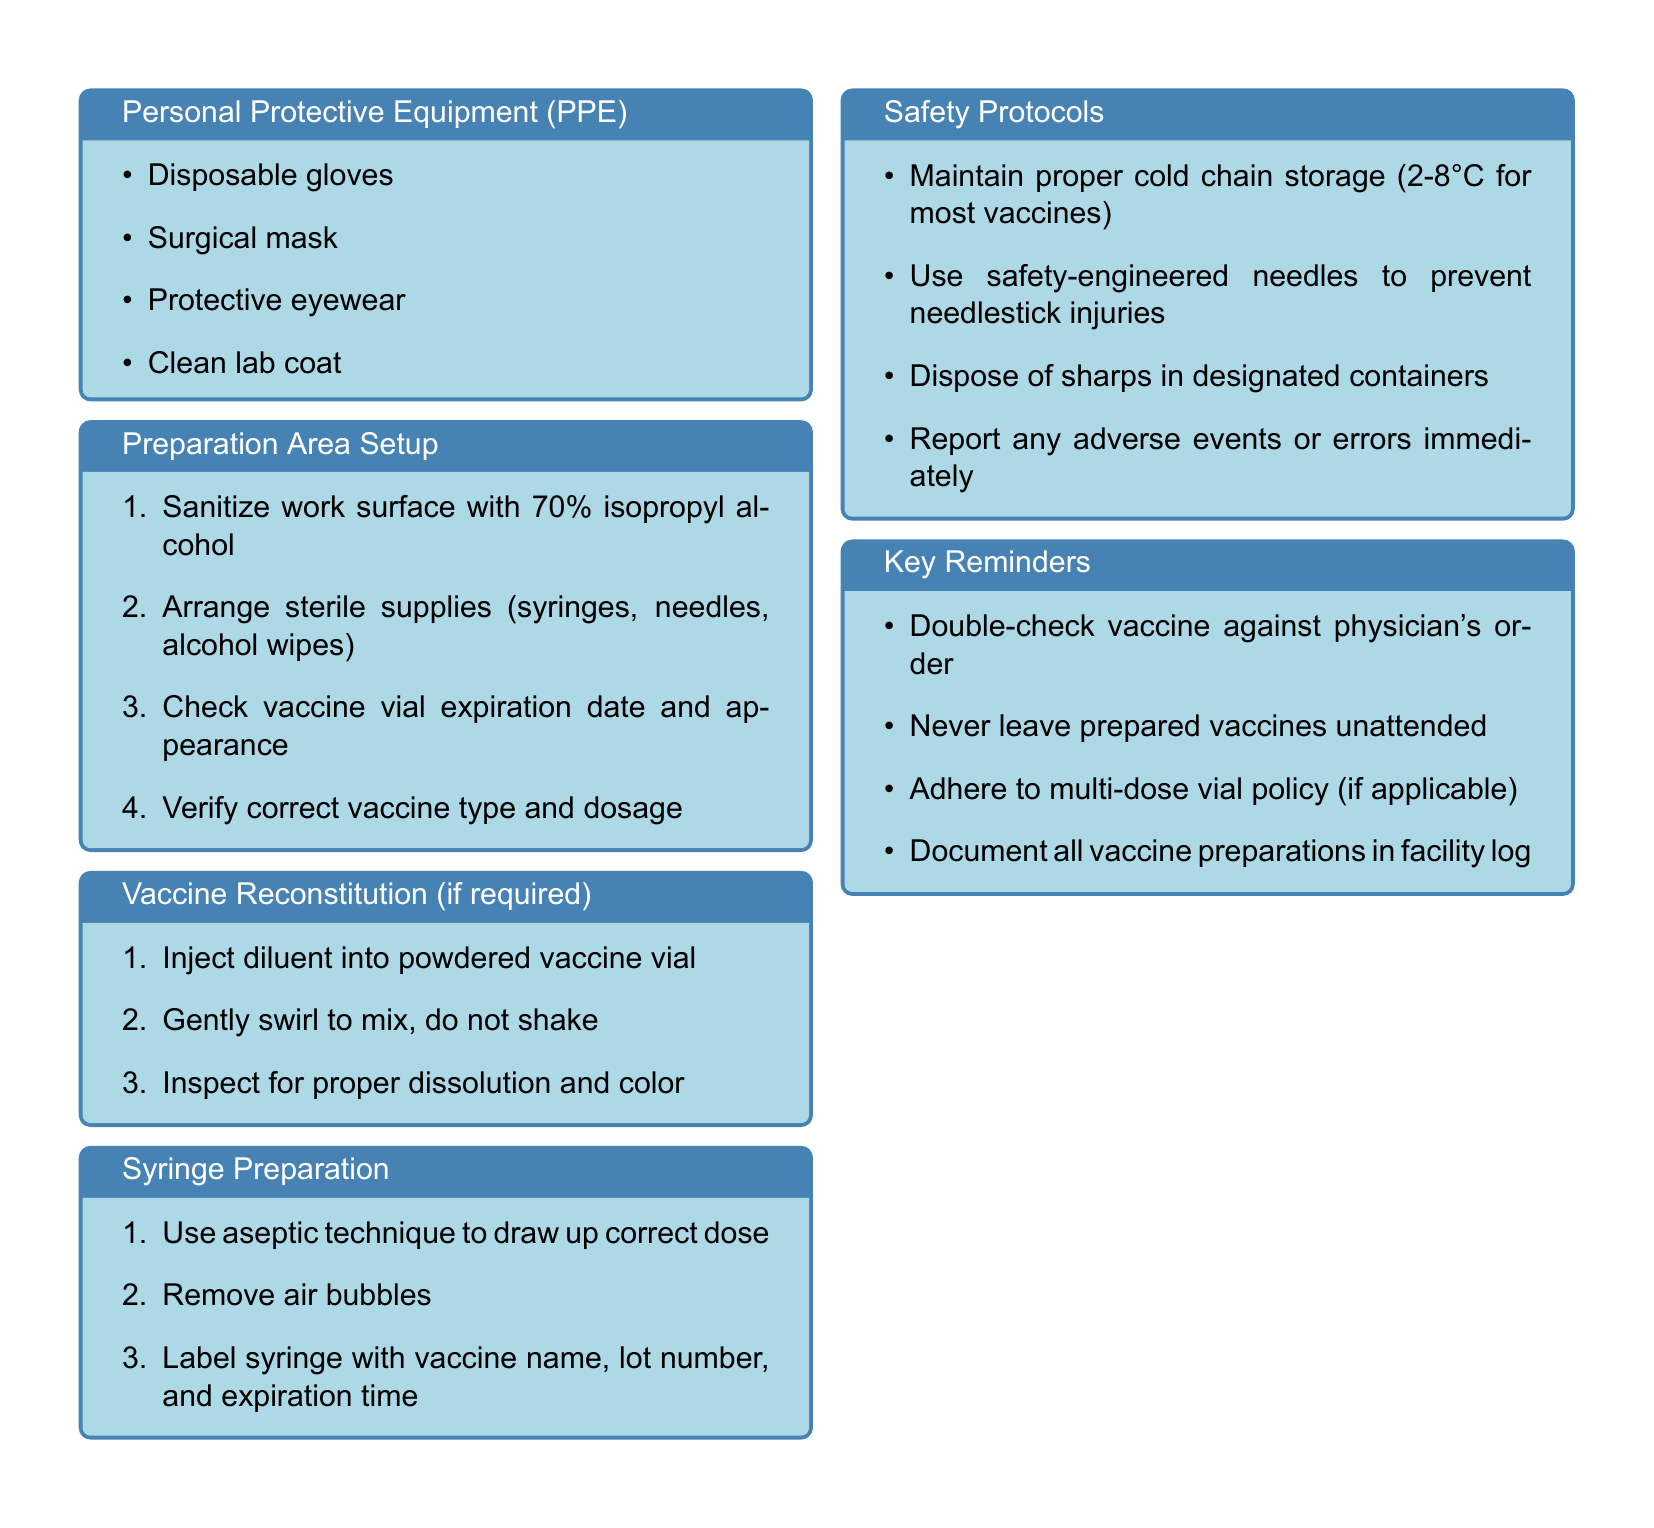What is the primary focus of this guide? The primary focus of the guide is to provide information on vaccine preparation techniques and safety protocols for medical technicians.
Answer: Vaccine Preparation and Safety What PPE is listed as essential? The document lists specific items required as personal protective equipment (PPE) for medical technicians to ensure safety while preparing vaccines.
Answer: Disposable gloves, Surgical mask, Protective eyewear, Clean lab coat What is the first step in the Preparation Area Setup? The first step in setting up the preparation area involves sanitizing the work surface with a specified alcohol concentration to eliminate potential contaminants.
Answer: Sanitize work surface with 70% isopropyl alcohol What should be done after injecting diluent into a powdered vaccine vial? After injecting the diluent, it's important to gently swirl the vial to mix the contents properly without creating foam.
Answer: Gently swirl to mix, do not shake What temperature range is designated for proper cold chain storage? The document specifies a temperature range that must be maintained for most vaccines to ensure their effectiveness during storage.
Answer: 2-8°C What should be checked against the physician's order? A critical safety step in the vaccine preparation process involves verifying that the prepared vaccine matches the specified physician’s order to prevent errors.
Answer: Double-check vaccine against physician's order What is required on a labeled syringe? The label on the syringe must contain specific identifying information to ensure proper tracking and usage of each vaccine dose.
Answer: Vaccine name, lot number, and expiration time What must be documented according to the Key Reminders? To maintain a proper record of vaccine preparations, it is essential to document specific actions taken during the vaccine preparation process.
Answer: Document all vaccine preparations in facility log 